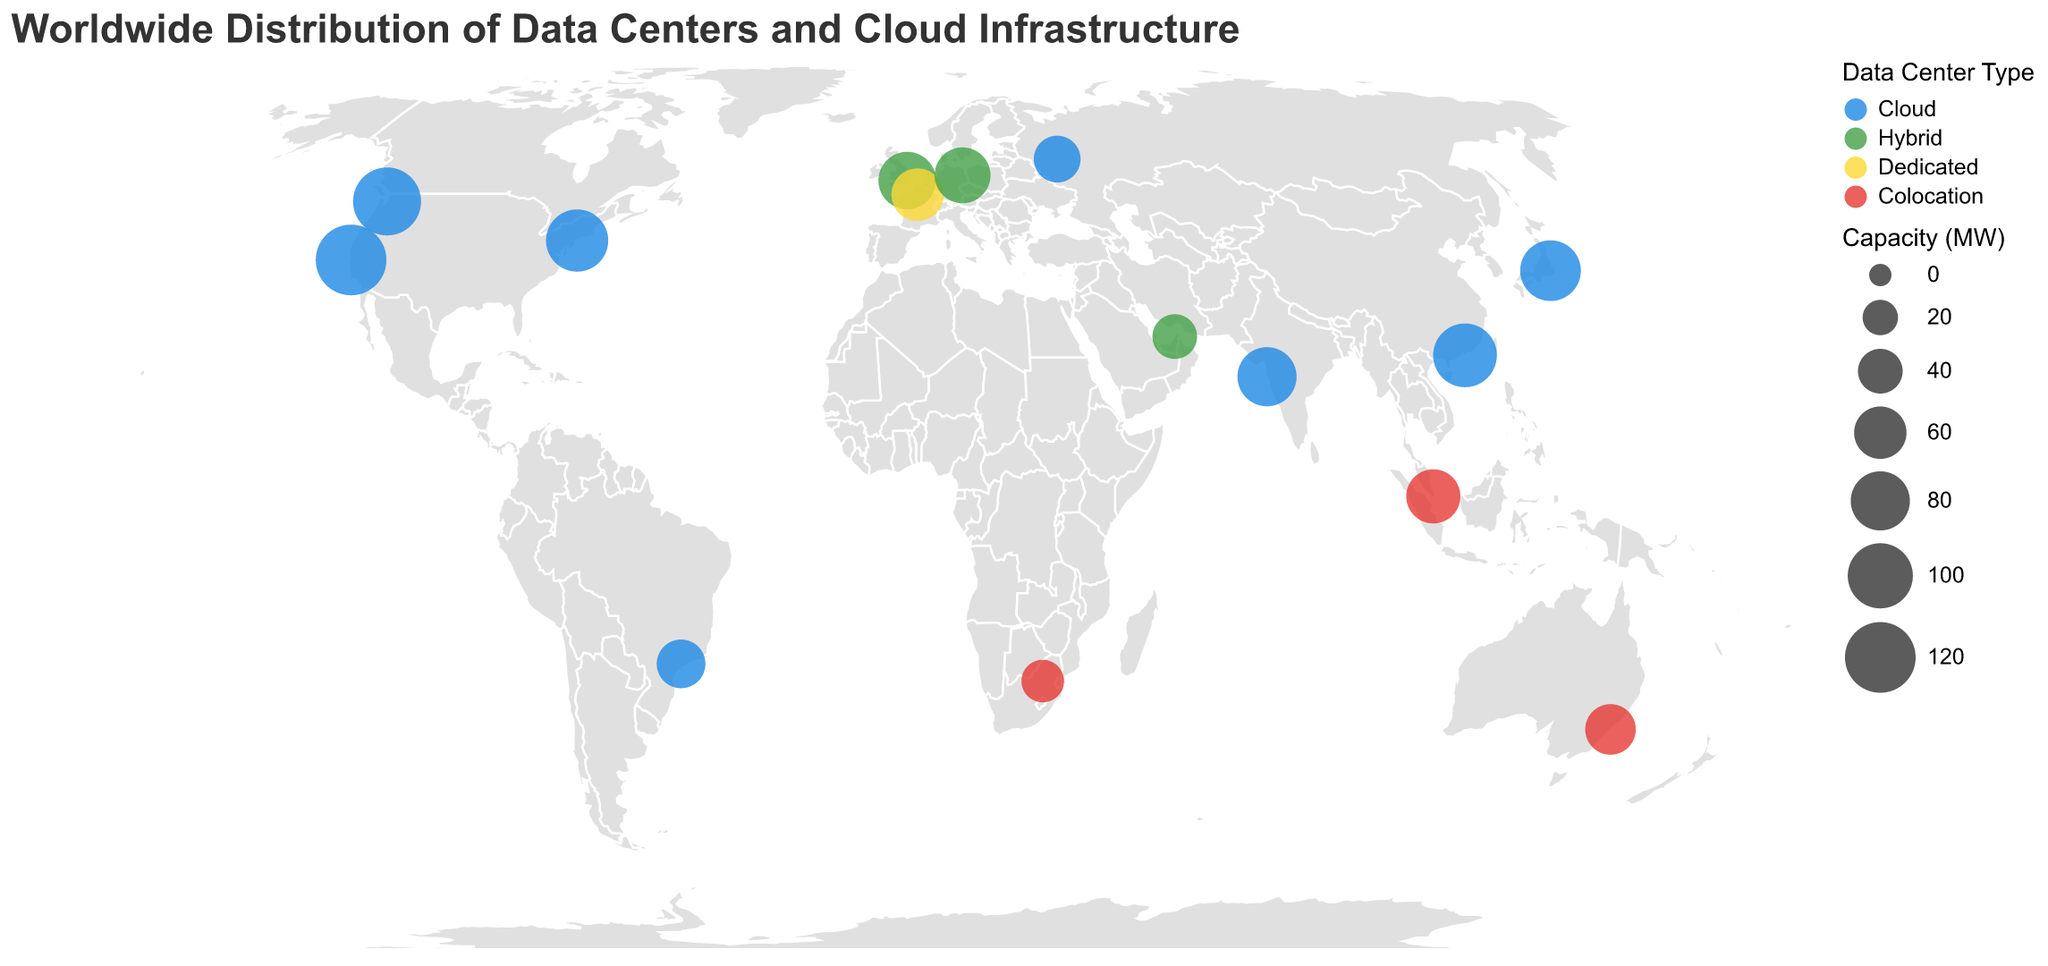What is the title of the figure? The title is printed at the top of the figure. It reads "Worldwide Distribution of Data Centers and Cloud Infrastructure."
Answer: Worldwide Distribution of Data Centers and Cloud Infrastructure How many companies operate cloud data centers according to the figure? By observing the color legend and corresponding data points, we can count the companies labeled as "Cloud." The companies are Google, Amazon, Microsoft, Alibaba, Tencent, Reliance Jio, Oracle, and Yandex, making a total of 8.
Answer: 8 Which company has the data center with the highest capacity, and what is its capacity? By looking at the size of the circles and cross-referencing the tooltip, the largest circle corresponds to Google, with a capacity of 120 MW.
Answer: Google, 120 MW What type of data center is the smallest in capacity, and where is it located? The smallest circle, based on size, represents Teraco with a Colocation data center located in South Africa, with a capacity of 35 MW.
Answer: Colocation, South Africa How many hybrid data centers are represented in the figure? By observing the color legend and counting the circles with the color corresponding to "Hybrid," there are three companies: IBM, Deutsche Telekom, and Etisalat.
Answer: 3 How does the capacity of Tencent's data center compare to Alibaba's? From the tooltip or the size of the circles, Tencent has a capacity of 95 MW, and Alibaba has 85 MW. Therefore, Tencent's capacity is greater.
Answer: Tencent's capacity is greater Which region has the highest concentration of cloud data centers? By looking at the geographic distribution and the color representing "Cloud" centers, North America (USA) has the highest concentration with three major companies: Google, Amazon, and Microsoft.
Answer: North America (USA) Are there more colocation data centers or dedicated data centers, and by how many? By counting from the color legend, there are three colocation data centers (Equinix, Digital Realty, Teraco) and one dedicated data center (OVHcloud). Therefore, there are two more colocation data centers than dedicated ones.
Answer: More colocation by 2 Which company operates in the highest number of unique types of data centers? By examining each company and the types they operate, no company operates in more than one type of data center alone based on the provided data.
Answer: None What is the total capacity of all data centers in Europe? In Europe, the data centers are IBM (75 MW in the UK), Deutsche Telekom (70 MW in Germany), and OVHcloud (60 MW in France). Summing these up gives 75 + 70 + 60 = 205 MW.
Answer: 205 MW 